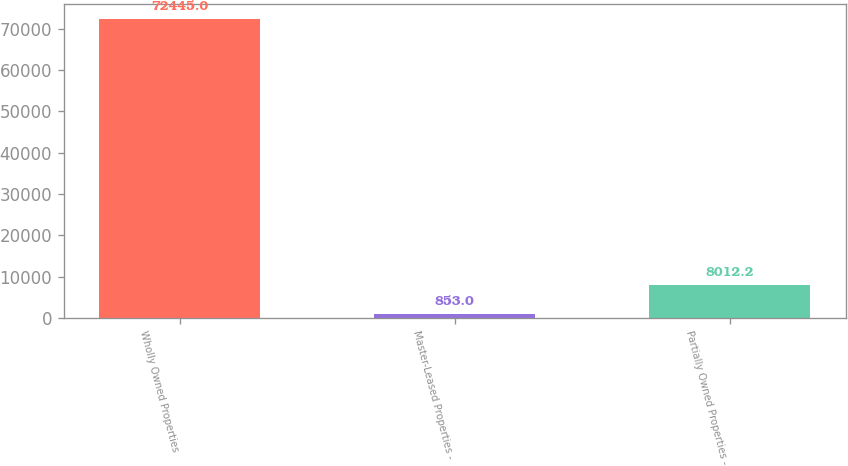Convert chart to OTSL. <chart><loc_0><loc_0><loc_500><loc_500><bar_chart><fcel>Wholly Owned Properties<fcel>Master-Leased Properties -<fcel>Partially Owned Properties -<nl><fcel>72445<fcel>853<fcel>8012.2<nl></chart> 